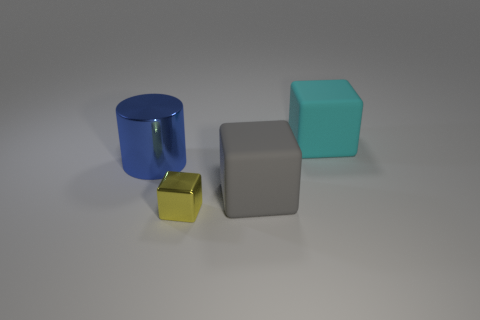Is the number of large cyan cubes that are behind the shiny block greater than the number of tiny green things?
Give a very brief answer. Yes. Are there any yellow shiny things left of the cyan block?
Ensure brevity in your answer.  Yes. Is the blue thing the same size as the cyan cube?
Offer a very short reply. Yes. What size is the other matte object that is the same shape as the big gray rubber object?
Give a very brief answer. Large. Are there any other things that are the same size as the metal cylinder?
Your response must be concise. Yes. The large thing that is on the left side of the cube on the left side of the large gray cube is made of what material?
Your answer should be very brief. Metal. Do the yellow thing and the gray thing have the same shape?
Your answer should be very brief. Yes. What number of large things are both to the left of the small thing and to the right of the small yellow cube?
Offer a terse response. 0. Are there the same number of big metallic objects that are to the left of the big cylinder and cyan rubber things in front of the yellow object?
Your response must be concise. Yes. Do the thing left of the small object and the thing that is in front of the gray object have the same size?
Give a very brief answer. No. 